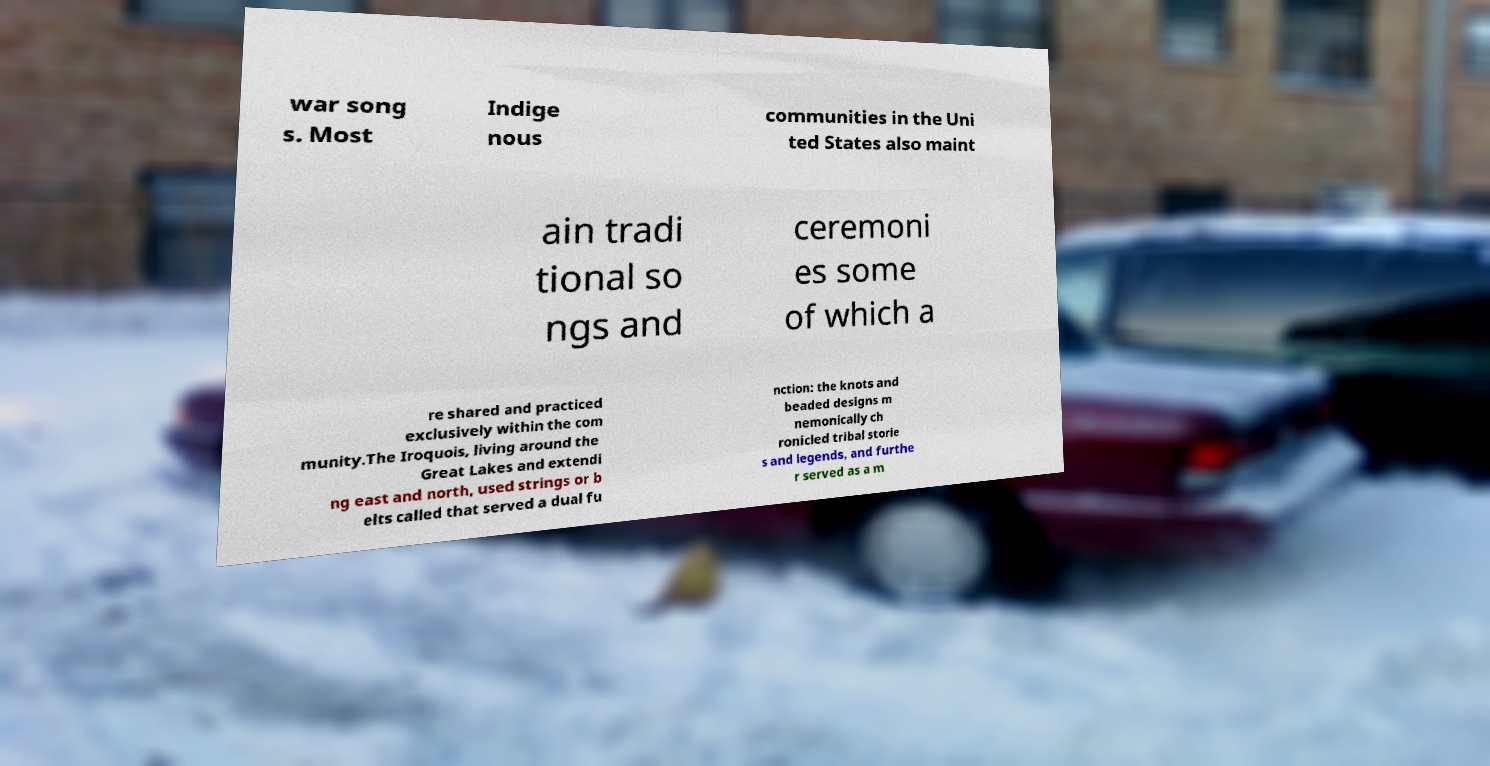Please read and relay the text visible in this image. What does it say? war song s. Most Indige nous communities in the Uni ted States also maint ain tradi tional so ngs and ceremoni es some of which a re shared and practiced exclusively within the com munity.The Iroquois, living around the Great Lakes and extendi ng east and north, used strings or b elts called that served a dual fu nction: the knots and beaded designs m nemonically ch ronicled tribal storie s and legends, and furthe r served as a m 